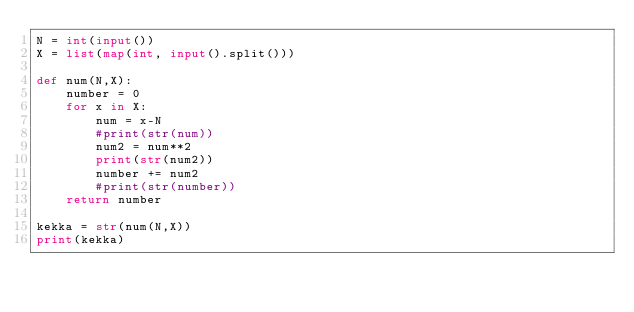Convert code to text. <code><loc_0><loc_0><loc_500><loc_500><_Python_>N = int(input())
X = list(map(int, input().split()))

def num(N,X):
    number = 0
    for x in X:
        num = x-N
        #print(str(num))
        num2 = num**2
        print(str(num2))
        number += num2
        #print(str(number))
    return number
    
kekka = str(num(N,X))
print(kekka)</code> 